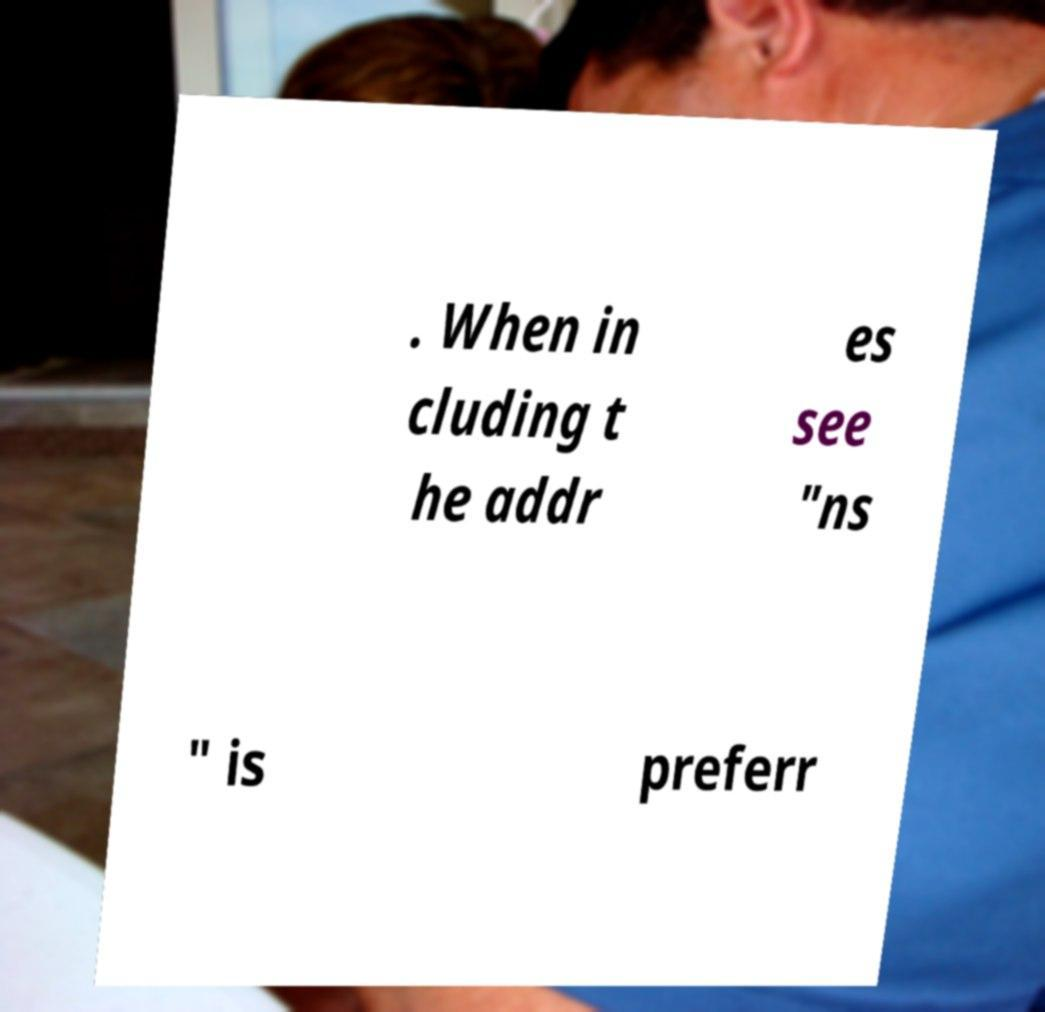What messages or text are displayed in this image? I need them in a readable, typed format. . When in cluding t he addr es see "ns " is preferr 